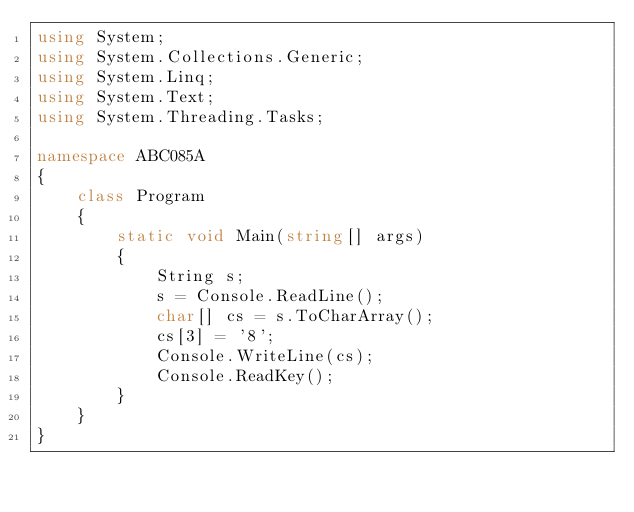<code> <loc_0><loc_0><loc_500><loc_500><_C#_>using System;
using System.Collections.Generic;
using System.Linq;
using System.Text;
using System.Threading.Tasks;

namespace ABC085A
{
    class Program
    {
        static void Main(string[] args)
        {
            String s;
            s = Console.ReadLine();
            char[] cs = s.ToCharArray();
            cs[3] = '8';
            Console.WriteLine(cs);
            Console.ReadKey();
        }
    }
}
</code> 